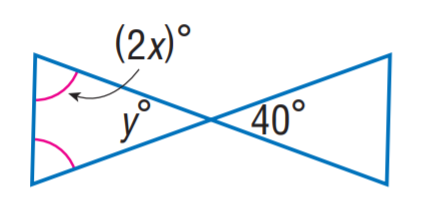Question: Find y.
Choices:
A. 30
B. 35
C. 40
D. 45
Answer with the letter. Answer: C Question: Find x.
Choices:
A. 30
B. 35
C. 40
D. 45
Answer with the letter. Answer: B 